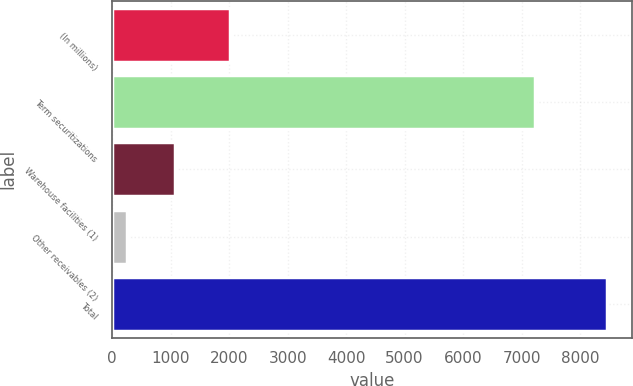Convert chart. <chart><loc_0><loc_0><loc_500><loc_500><bar_chart><fcel>(In millions)<fcel>Term securitizations<fcel>Warehouse facilities (1)<fcel>Other receivables (2)<fcel>Total<nl><fcel>2015<fcel>7226.5<fcel>1067.45<fcel>246.2<fcel>8458.7<nl></chart> 